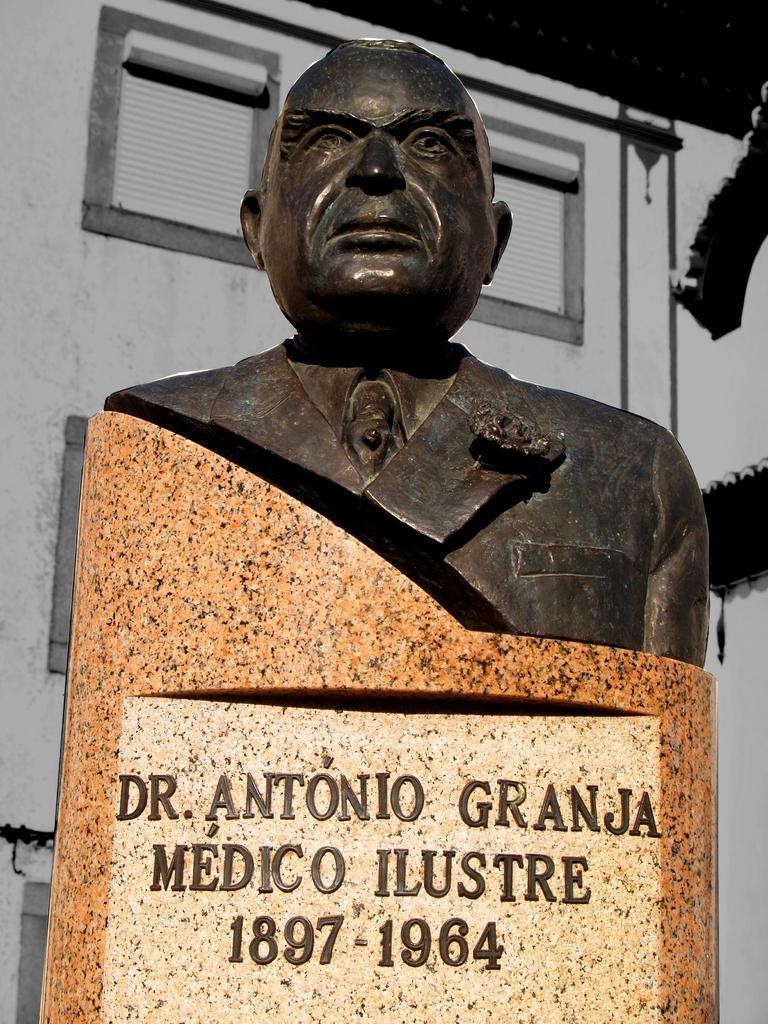Can you describe this image briefly? In this image we can see a statue on a pedestal and we can see something is written on the pedestal. In the background we can see a building. 